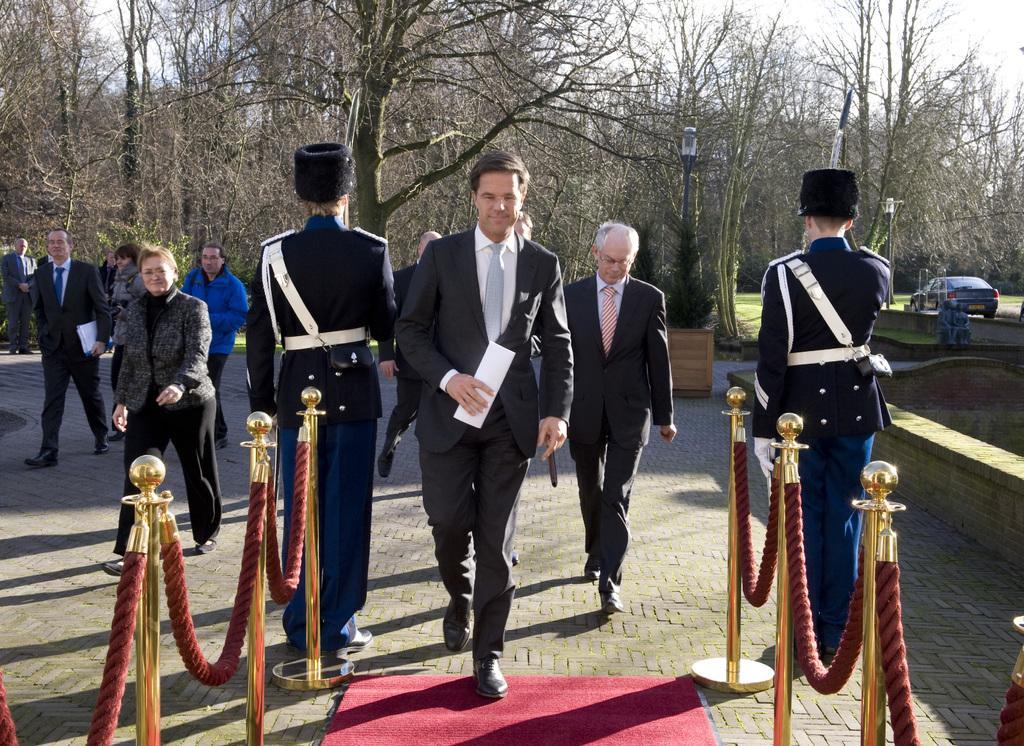Describe this image in one or two sentences. In this picture, we can see a few people carrying some objects and we can see some poles, rope, mat, vehicles, trees and some objects on the floor and we can see the sky. 